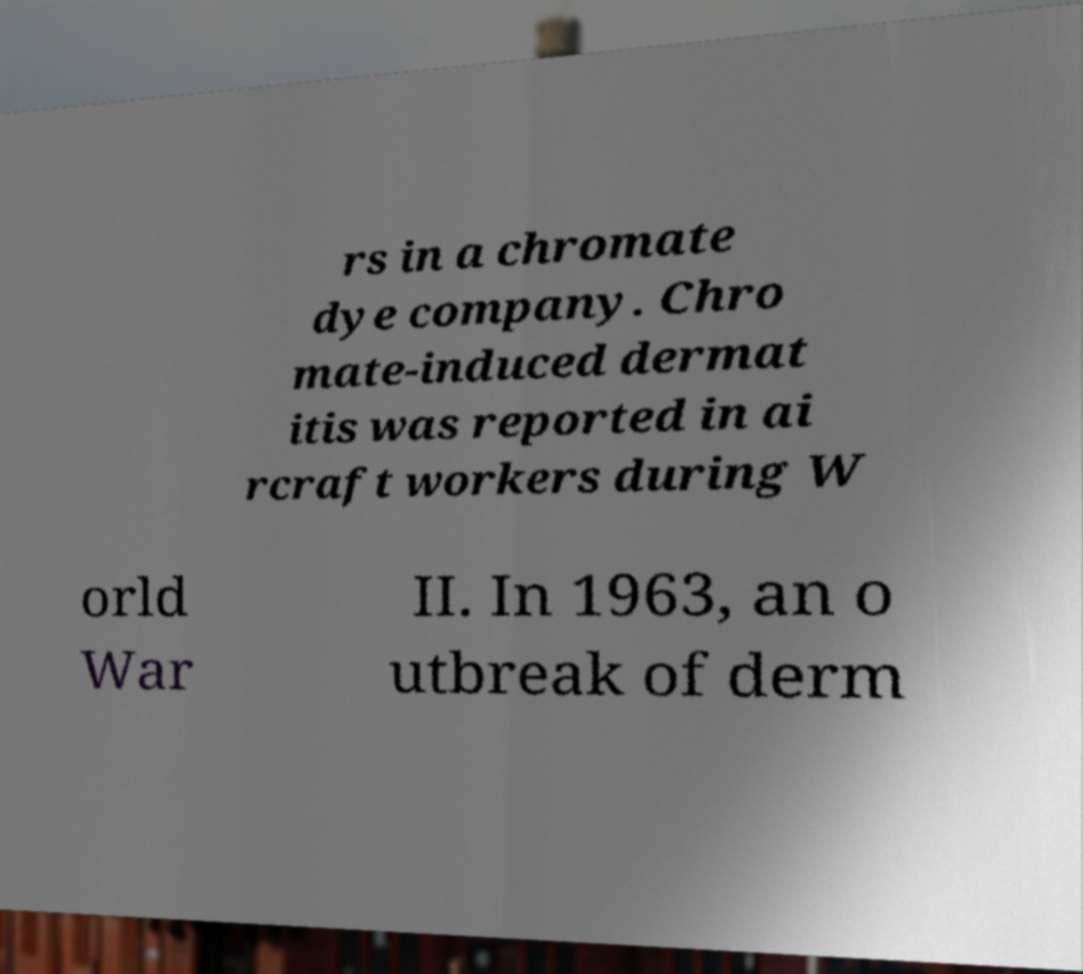Could you extract and type out the text from this image? rs in a chromate dye company. Chro mate-induced dermat itis was reported in ai rcraft workers during W orld War II. In 1963, an o utbreak of derm 